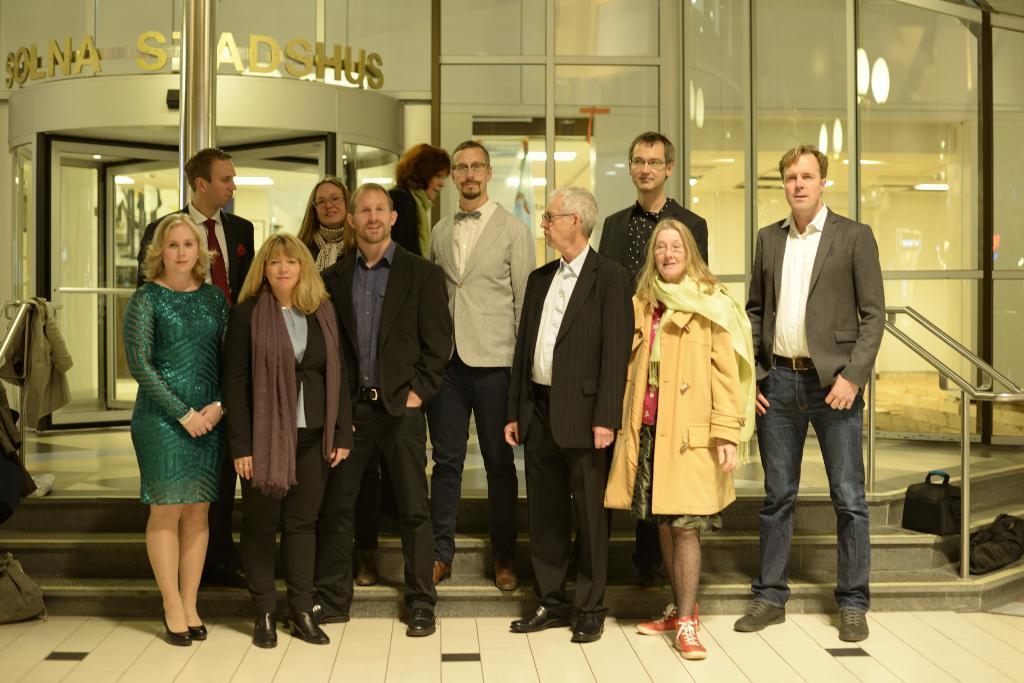Please provide a concise description of this image. In this picture there are people standing and we can see bags, clothes, railings, steps and glass, through this glass we can see lights and text. 